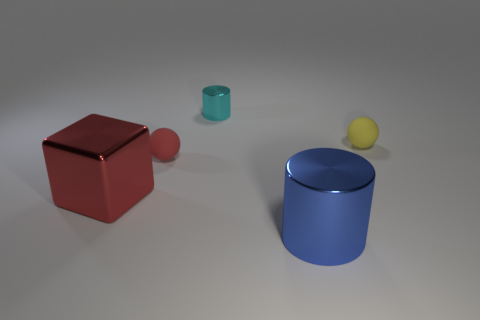Is the block the same color as the small cylinder?
Ensure brevity in your answer.  No. There is a cylinder in front of the small metal thing; does it have the same size as the red metal cube that is on the left side of the cyan shiny cylinder?
Provide a short and direct response. Yes. The object that is both to the right of the tiny cyan metal object and to the left of the tiny yellow object has what shape?
Ensure brevity in your answer.  Cylinder. Are there any rubber things that have the same color as the big cube?
Your response must be concise. Yes. Is there a purple ball?
Your answer should be compact. No. The tiny rubber sphere that is on the right side of the large blue cylinder is what color?
Make the answer very short. Yellow. There is a blue shiny thing; is it the same size as the shiny object left of the small cylinder?
Offer a terse response. Yes. What size is the metallic object that is in front of the small yellow object and right of the large red cube?
Offer a terse response. Large. Is there a tiny red ball that has the same material as the yellow ball?
Provide a short and direct response. Yes. What shape is the tiny cyan metal object?
Give a very brief answer. Cylinder. 